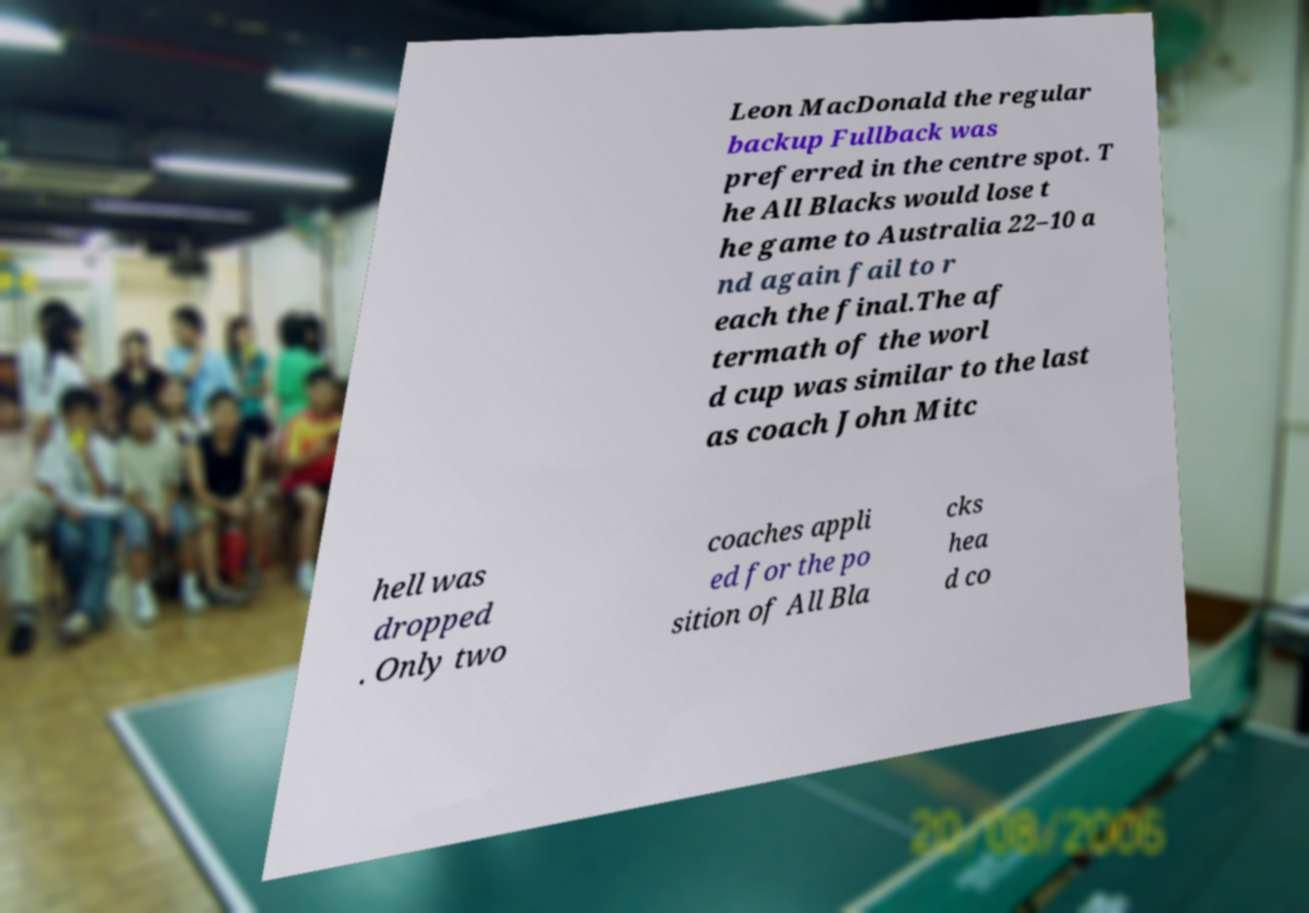What messages or text are displayed in this image? I need them in a readable, typed format. Leon MacDonald the regular backup Fullback was preferred in the centre spot. T he All Blacks would lose t he game to Australia 22–10 a nd again fail to r each the final.The af termath of the worl d cup was similar to the last as coach John Mitc hell was dropped . Only two coaches appli ed for the po sition of All Bla cks hea d co 